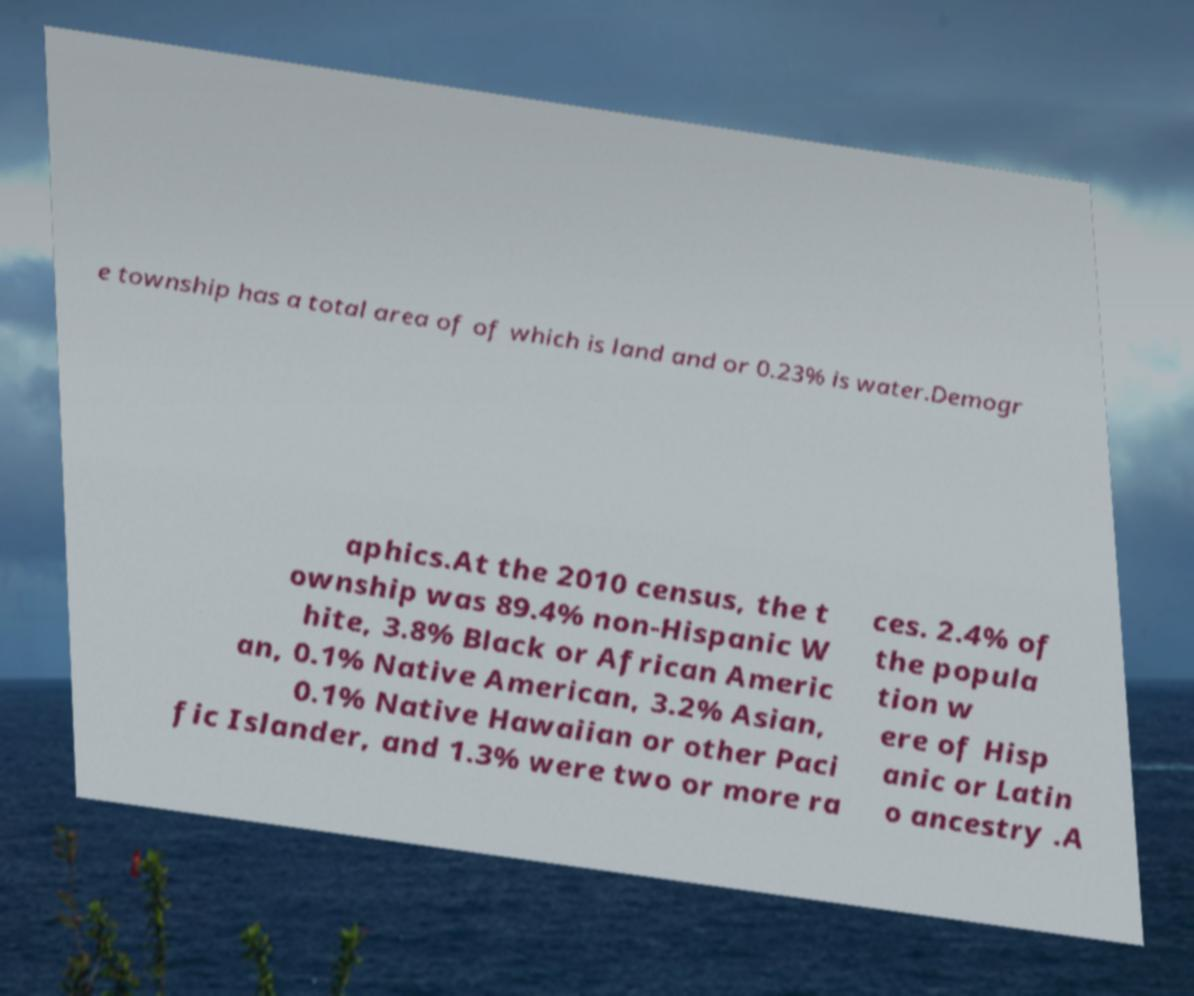Could you assist in decoding the text presented in this image and type it out clearly? e township has a total area of of which is land and or 0.23% is water.Demogr aphics.At the 2010 census, the t ownship was 89.4% non-Hispanic W hite, 3.8% Black or African Americ an, 0.1% Native American, 3.2% Asian, 0.1% Native Hawaiian or other Paci fic Islander, and 1.3% were two or more ra ces. 2.4% of the popula tion w ere of Hisp anic or Latin o ancestry .A 